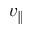Convert formula to latex. <formula><loc_0><loc_0><loc_500><loc_500>v _ { \| }</formula> 